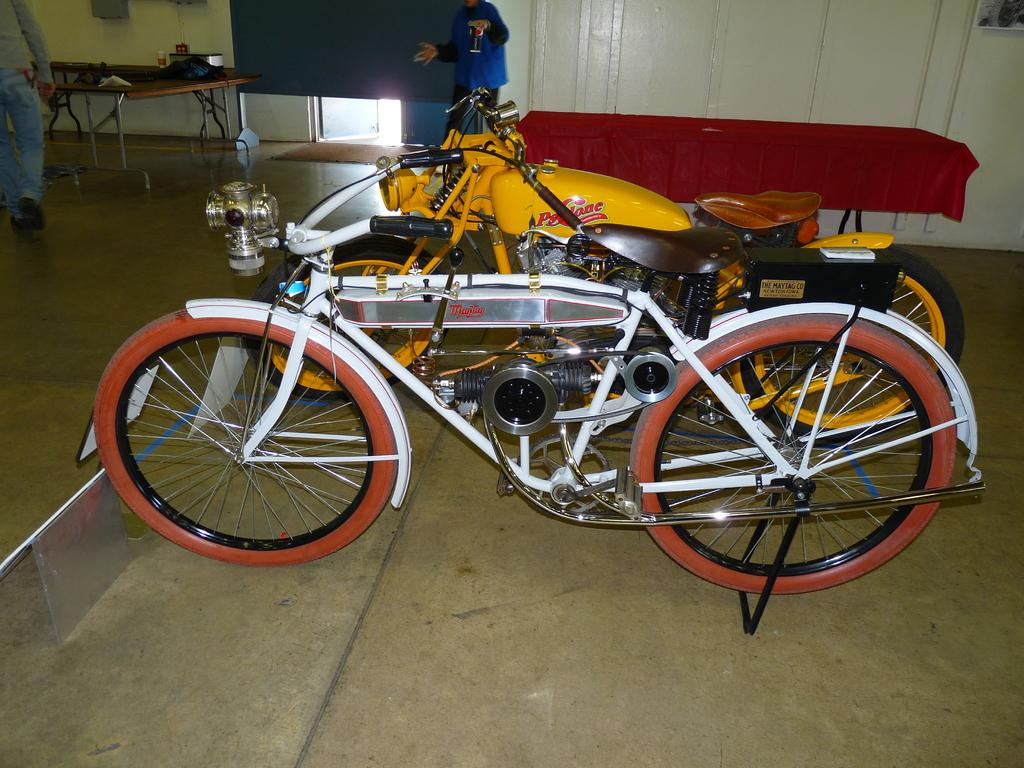What types of vehicles are in the image? There are two motor vehicles in the image. What is on the table in the image? There is a table with a red cloth on it. How many people are in the image? There are two persons standing in front of the table. What type of fuel is being used by the motor vehicles in the image? The provided facts do not mention the type of fuel being used by the motor vehicles, so it cannot be determined from the image. Can you describe the field where the motor vehicles are parked? There is no field present in the image; it only features two motor vehicles, a table with a red cloth, and two persons standing in front of the table. 